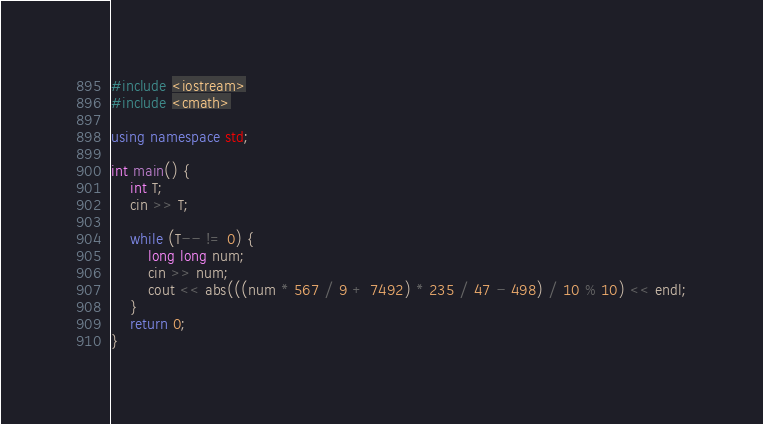Convert code to text. <code><loc_0><loc_0><loc_500><loc_500><_C++_>#include <iostream>
#include <cmath>

using namespace std;

int main() {
    int T;
    cin >> T;

    while (T-- != 0) {
        long long num;
        cin >> num;
        cout << abs(((num * 567 / 9 + 7492) * 235 / 47 - 498) / 10 % 10) << endl;
    }
    return 0;
}</code> 